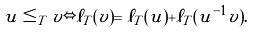<formula> <loc_0><loc_0><loc_500><loc_500>u \leq _ { T } v \Leftrightarrow \ell _ { T } ( v ) = \ell _ { T } ( u ) + \ell _ { T } ( u ^ { - 1 } v ) .</formula> 